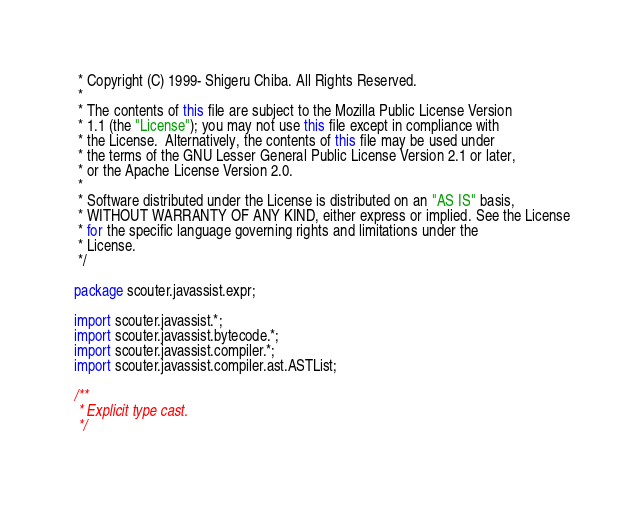<code> <loc_0><loc_0><loc_500><loc_500><_Java_> * Copyright (C) 1999- Shigeru Chiba. All Rights Reserved.
 *
 * The contents of this file are subject to the Mozilla Public License Version
 * 1.1 (the "License"); you may not use this file except in compliance with
 * the License.  Alternatively, the contents of this file may be used under
 * the terms of the GNU Lesser General Public License Version 2.1 or later,
 * or the Apache License Version 2.0.
 *
 * Software distributed under the License is distributed on an "AS IS" basis,
 * WITHOUT WARRANTY OF ANY KIND, either express or implied. See the License
 * for the specific language governing rights and limitations under the
 * License.
 */

package scouter.javassist.expr;

import scouter.javassist.*;
import scouter.javassist.bytecode.*;
import scouter.javassist.compiler.*;
import scouter.javassist.compiler.ast.ASTList;

/**
 * Explicit type cast.
 */</code> 